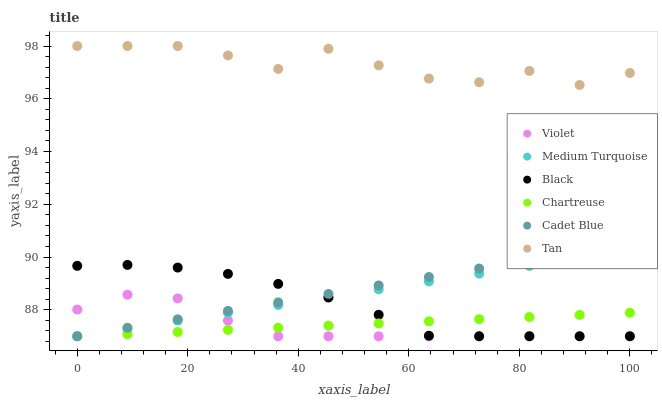Does Violet have the minimum area under the curve?
Answer yes or no. Yes. Does Tan have the maximum area under the curve?
Answer yes or no. Yes. Does Chartreuse have the minimum area under the curve?
Answer yes or no. No. Does Chartreuse have the maximum area under the curve?
Answer yes or no. No. Is Chartreuse the smoothest?
Answer yes or no. Yes. Is Tan the roughest?
Answer yes or no. Yes. Is Black the smoothest?
Answer yes or no. No. Is Black the roughest?
Answer yes or no. No. Does Cadet Blue have the lowest value?
Answer yes or no. Yes. Does Tan have the lowest value?
Answer yes or no. No. Does Tan have the highest value?
Answer yes or no. Yes. Does Black have the highest value?
Answer yes or no. No. Is Cadet Blue less than Tan?
Answer yes or no. Yes. Is Tan greater than Cadet Blue?
Answer yes or no. Yes. Does Chartreuse intersect Cadet Blue?
Answer yes or no. Yes. Is Chartreuse less than Cadet Blue?
Answer yes or no. No. Is Chartreuse greater than Cadet Blue?
Answer yes or no. No. Does Cadet Blue intersect Tan?
Answer yes or no. No. 